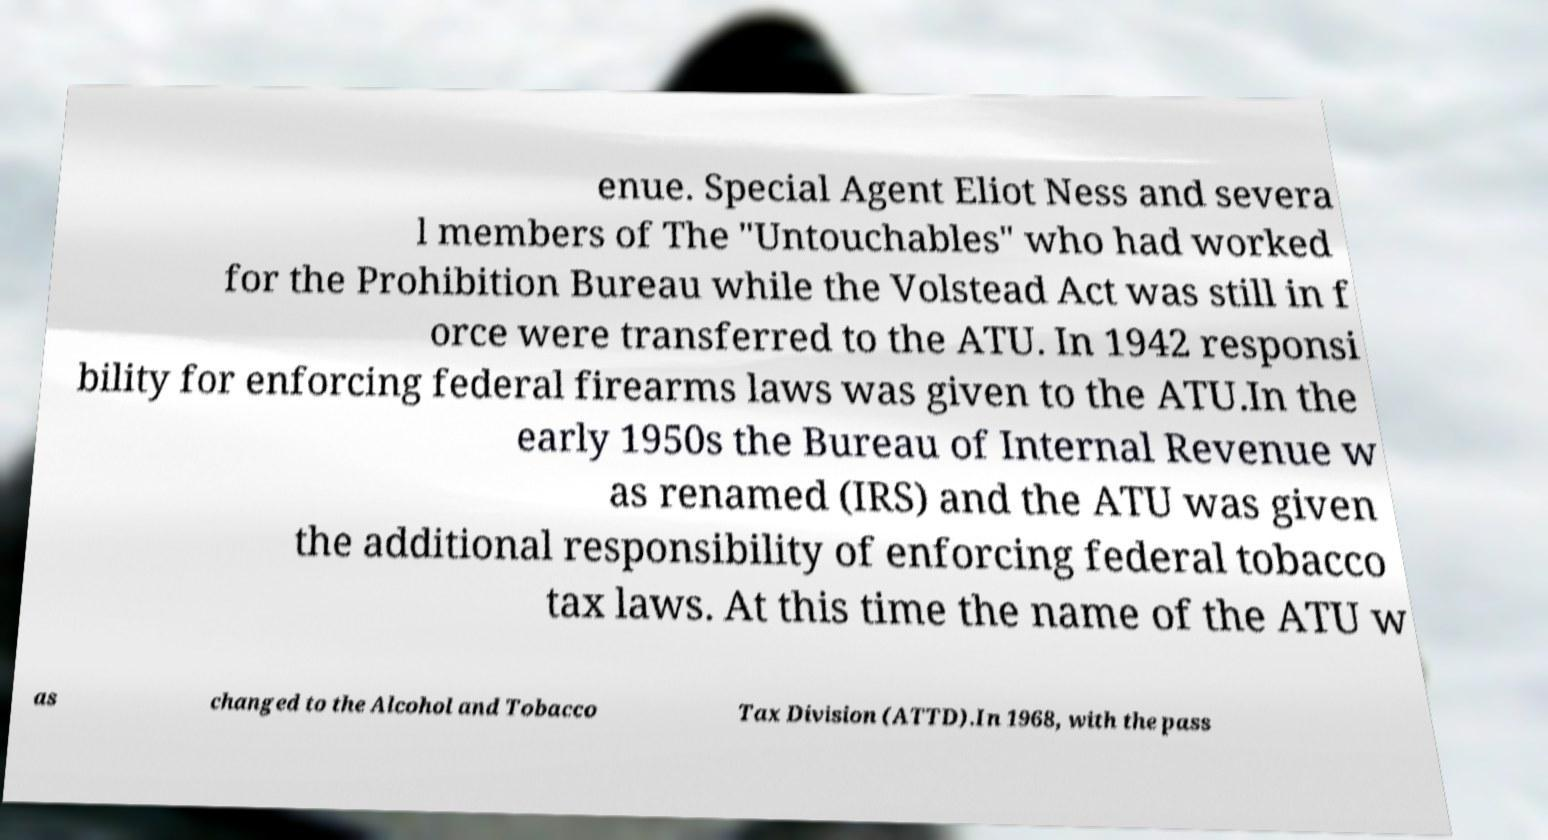There's text embedded in this image that I need extracted. Can you transcribe it verbatim? enue. Special Agent Eliot Ness and severa l members of The "Untouchables" who had worked for the Prohibition Bureau while the Volstead Act was still in f orce were transferred to the ATU. In 1942 responsi bility for enforcing federal firearms laws was given to the ATU.In the early 1950s the Bureau of Internal Revenue w as renamed (IRS) and the ATU was given the additional responsibility of enforcing federal tobacco tax laws. At this time the name of the ATU w as changed to the Alcohol and Tobacco Tax Division (ATTD).In 1968, with the pass 